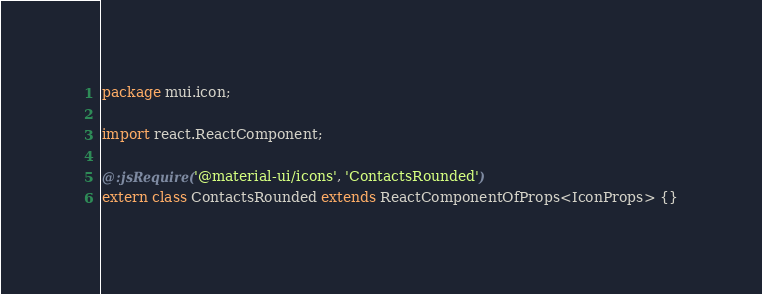<code> <loc_0><loc_0><loc_500><loc_500><_Haxe_>package mui.icon;

import react.ReactComponent;

@:jsRequire('@material-ui/icons', 'ContactsRounded')
extern class ContactsRounded extends ReactComponentOfProps<IconProps> {}
</code> 